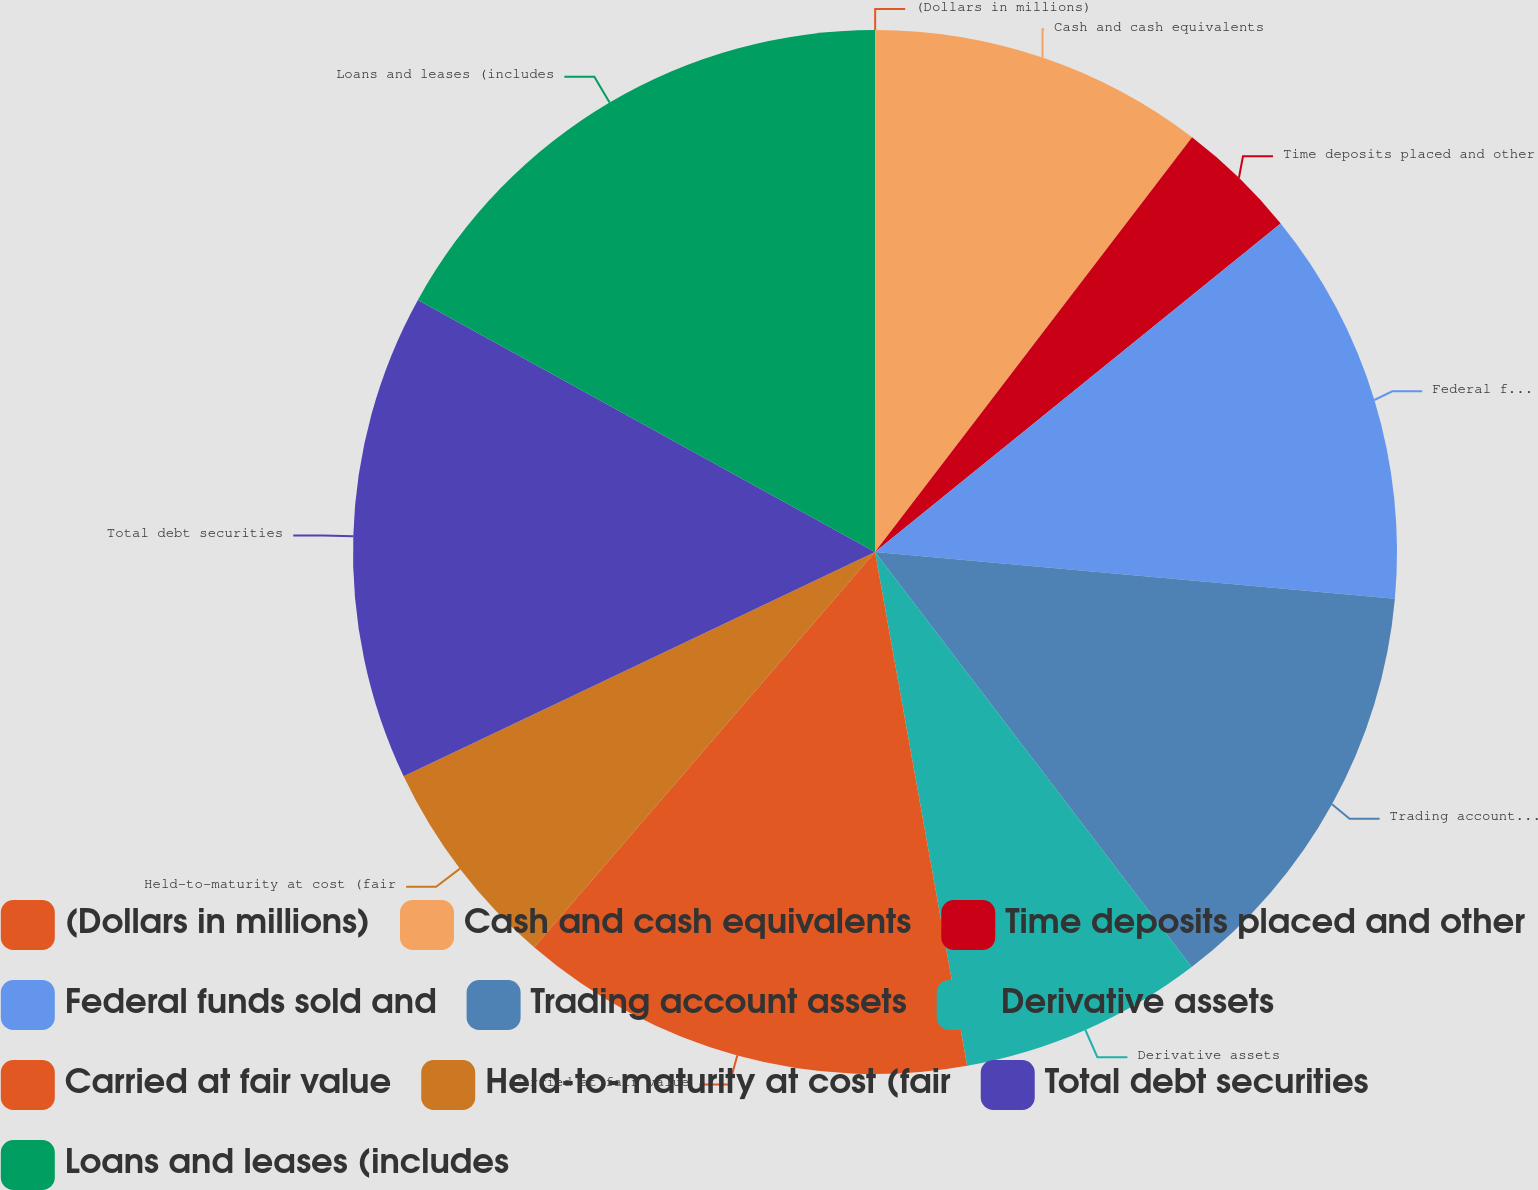Convert chart to OTSL. <chart><loc_0><loc_0><loc_500><loc_500><pie_chart><fcel>(Dollars in millions)<fcel>Cash and cash equivalents<fcel>Time deposits placed and other<fcel>Federal funds sold and<fcel>Trading account assets<fcel>Derivative assets<fcel>Carried at fair value<fcel>Held-to-maturity at cost (fair<fcel>Total debt securities<fcel>Loans and leases (includes<nl><fcel>0.01%<fcel>10.38%<fcel>3.78%<fcel>12.26%<fcel>13.2%<fcel>7.55%<fcel>14.15%<fcel>6.61%<fcel>15.09%<fcel>16.98%<nl></chart> 